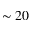Convert formula to latex. <formula><loc_0><loc_0><loc_500><loc_500>\sim 2 0</formula> 